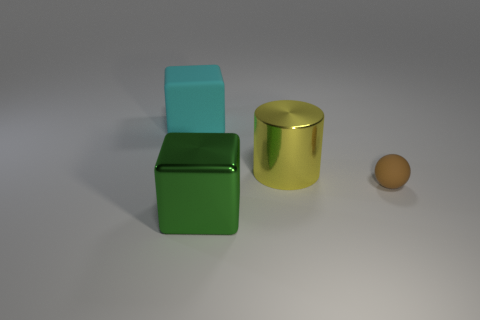What number of other small brown spheres have the same material as the tiny ball?
Your answer should be very brief. 0. There is a thing that is in front of the sphere; what material is it?
Offer a very short reply. Metal. What is the shape of the big shiny object to the right of the large cube on the right side of the rubber object that is on the left side of the green thing?
Offer a terse response. Cylinder. There is a matte object that is in front of the large yellow cylinder; is its color the same as the block that is behind the big metallic cylinder?
Your answer should be very brief. No. Is the number of brown things that are in front of the large green object less than the number of large matte objects that are left of the shiny cylinder?
Offer a terse response. Yes. Is there any other thing that has the same shape as the big yellow object?
Provide a short and direct response. No. There is another object that is the same shape as the big cyan rubber object; what color is it?
Ensure brevity in your answer.  Green. Is the shape of the cyan thing the same as the thing in front of the brown matte object?
Provide a succinct answer. Yes. What number of things are either matte things that are in front of the big yellow cylinder or metallic objects that are behind the green object?
Ensure brevity in your answer.  2. What is the ball made of?
Provide a short and direct response. Rubber. 